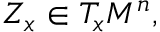Convert formula to latex. <formula><loc_0><loc_0><loc_500><loc_500>Z _ { x } \in T _ { x } M ^ { n } ,</formula> 